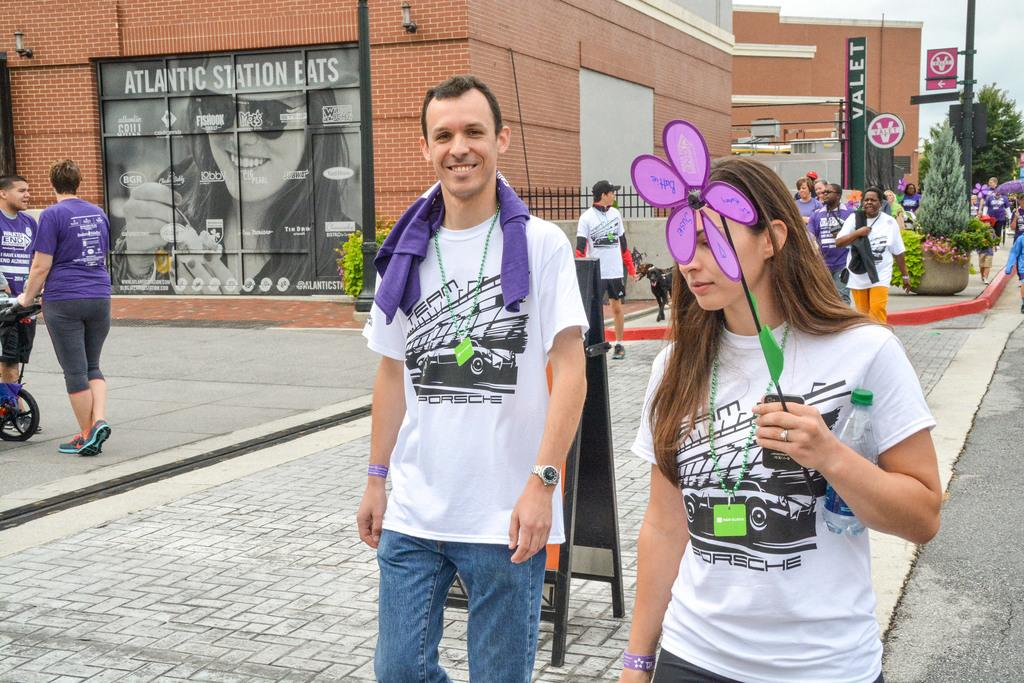What are the people in the image doing? The people in the image are standing on the ground. What can be seen in the background of the image? There are buildings, trees, plants, lights on the wall, and other objects visible in the background. What is visible in the sky in the image? The sky is visible in the image. How much range does the blood have in the image? There is no blood present in the image, so it does not have any range. What type of dust can be seen in the image? There is no dust visible in the image. 